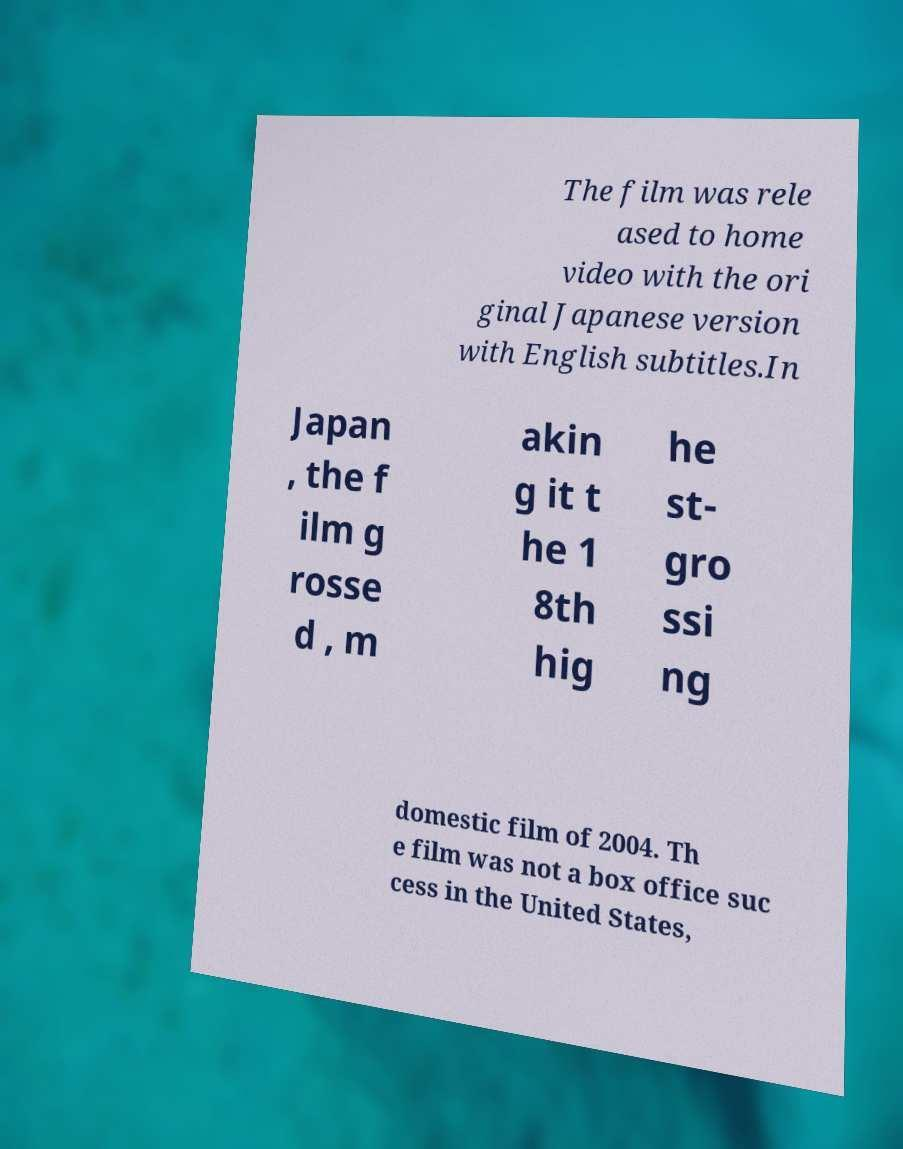There's text embedded in this image that I need extracted. Can you transcribe it verbatim? The film was rele ased to home video with the ori ginal Japanese version with English subtitles.In Japan , the f ilm g rosse d , m akin g it t he 1 8th hig he st- gro ssi ng domestic film of 2004. Th e film was not a box office suc cess in the United States, 